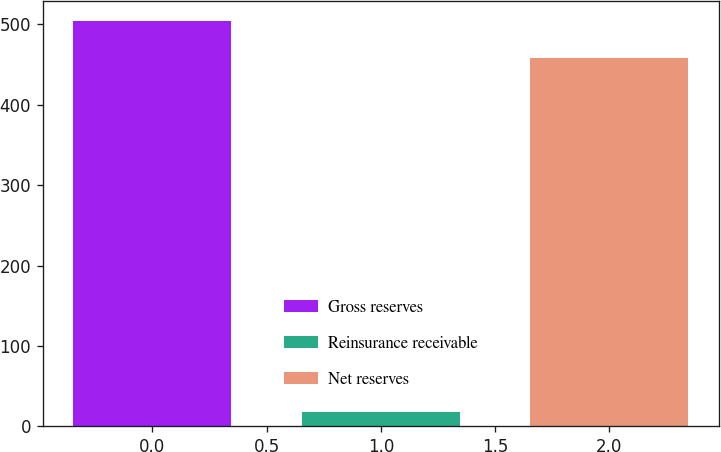Convert chart to OTSL. <chart><loc_0><loc_0><loc_500><loc_500><bar_chart><fcel>Gross reserves<fcel>Reinsurance receivable<fcel>Net reserves<nl><fcel>504.02<fcel>18<fcel>458.2<nl></chart> 